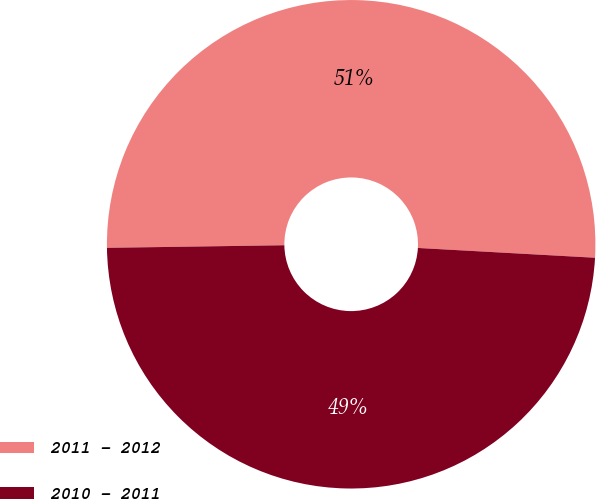<chart> <loc_0><loc_0><loc_500><loc_500><pie_chart><fcel>2011 - 2012<fcel>2010 - 2011<nl><fcel>51.11%<fcel>48.89%<nl></chart> 